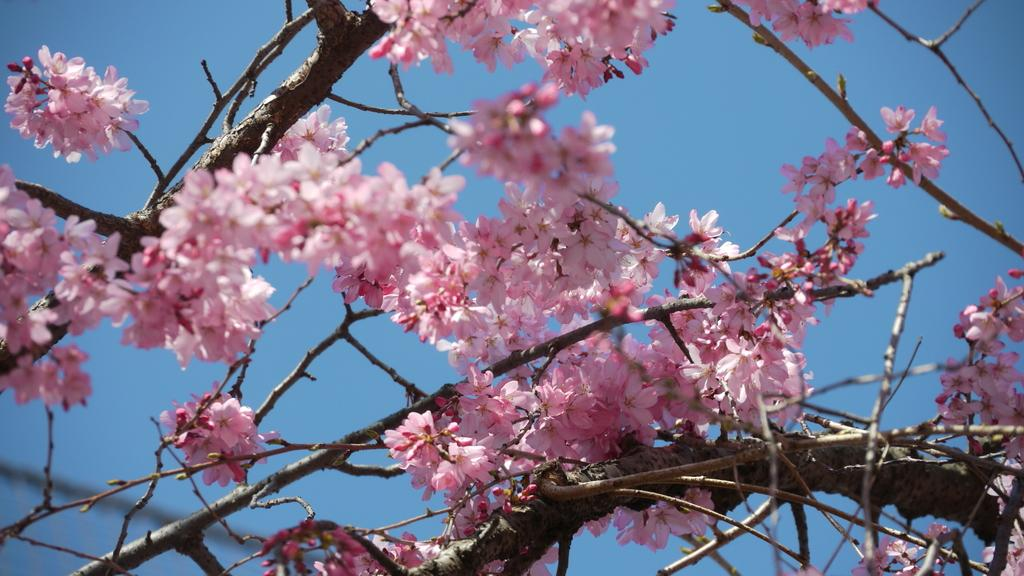What type of plant can be seen in the image? There is a tree in the image. What specific feature can be observed on the tree? The tree has flowers. What part of the natural environment is visible in the image? The sky is visible in the background of the image. How does the tree push the clouds in the image? The tree does not push the clouds in the image; it is a static object in the scene. 